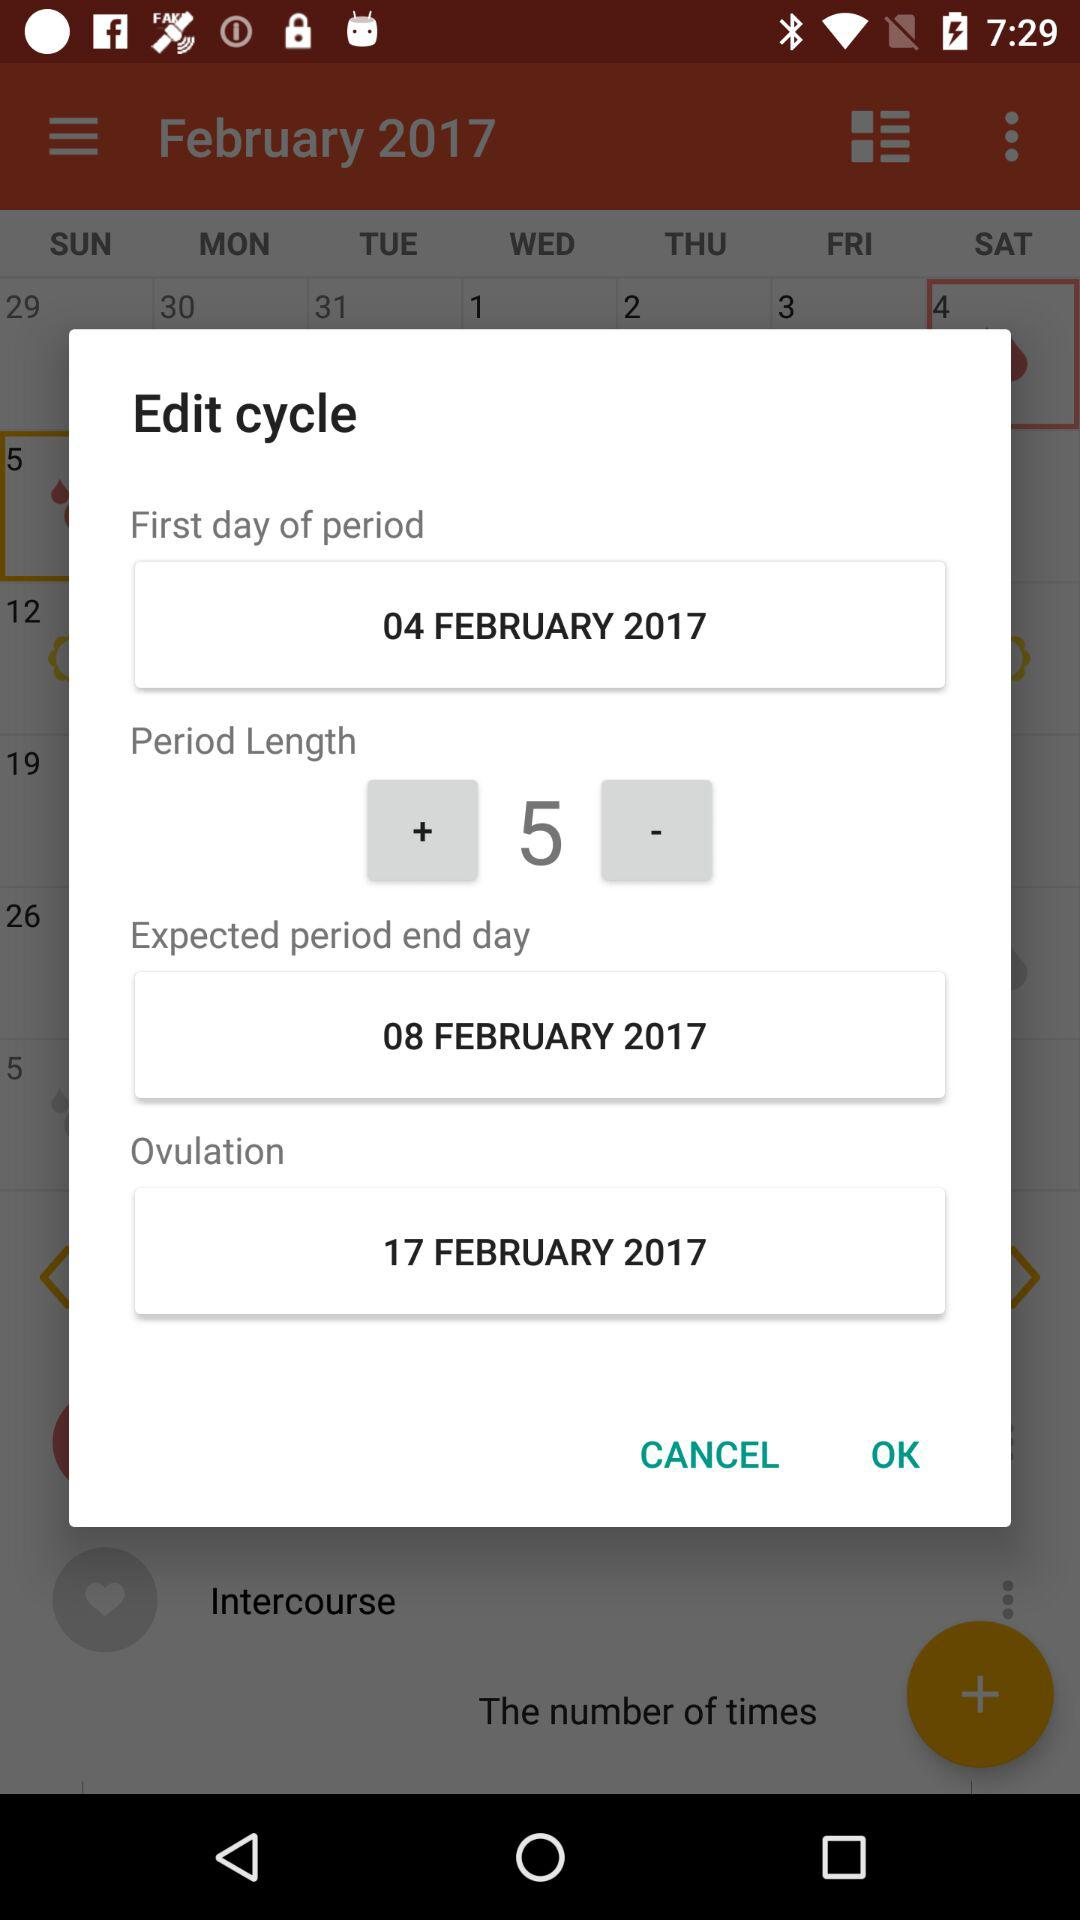How many days until Valentine's Day?
When the provided information is insufficient, respond with <no answer>. <no answer> 